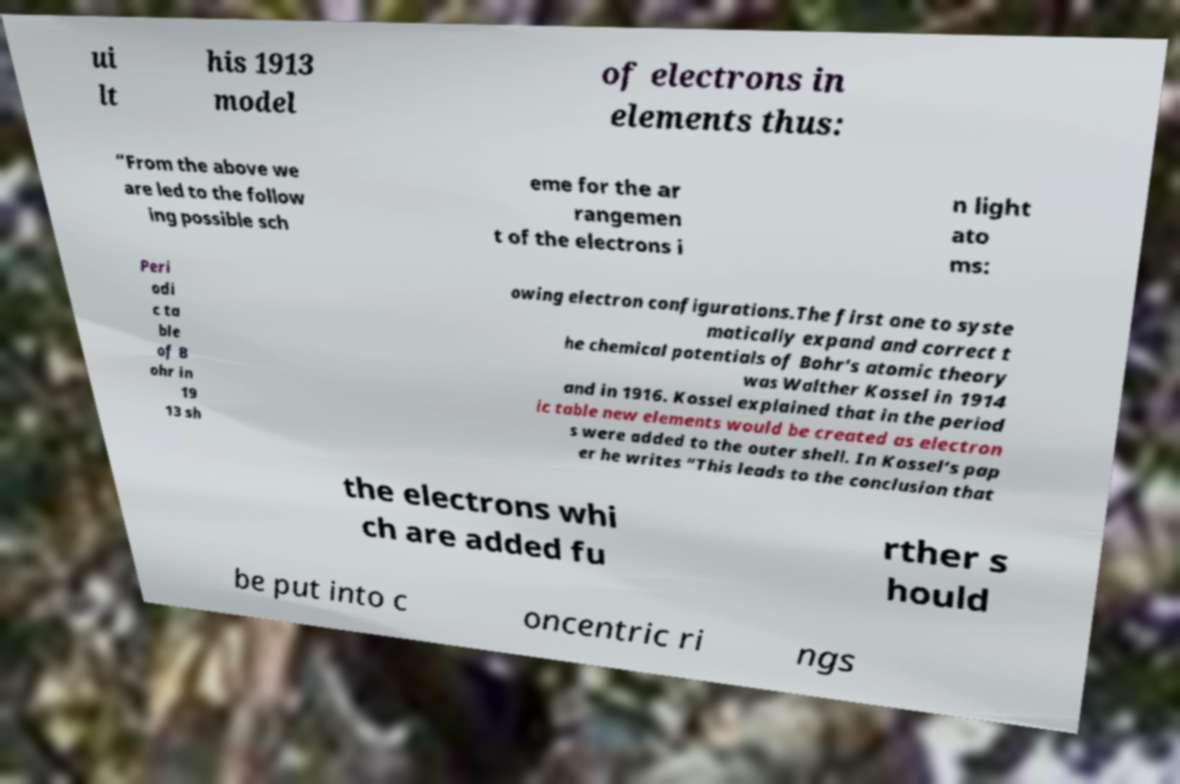There's text embedded in this image that I need extracted. Can you transcribe it verbatim? ui lt his 1913 model of electrons in elements thus: “From the above we are led to the follow ing possible sch eme for the ar rangemen t of the electrons i n light ato ms: Peri odi c ta ble of B ohr in 19 13 sh owing electron configurations.The first one to syste matically expand and correct t he chemical potentials of Bohr’s atomic theory was Walther Kossel in 1914 and in 1916. Kossel explained that in the period ic table new elements would be created as electron s were added to the outer shell. In Kossel’s pap er he writes “This leads to the conclusion that the electrons whi ch are added fu rther s hould be put into c oncentric ri ngs 